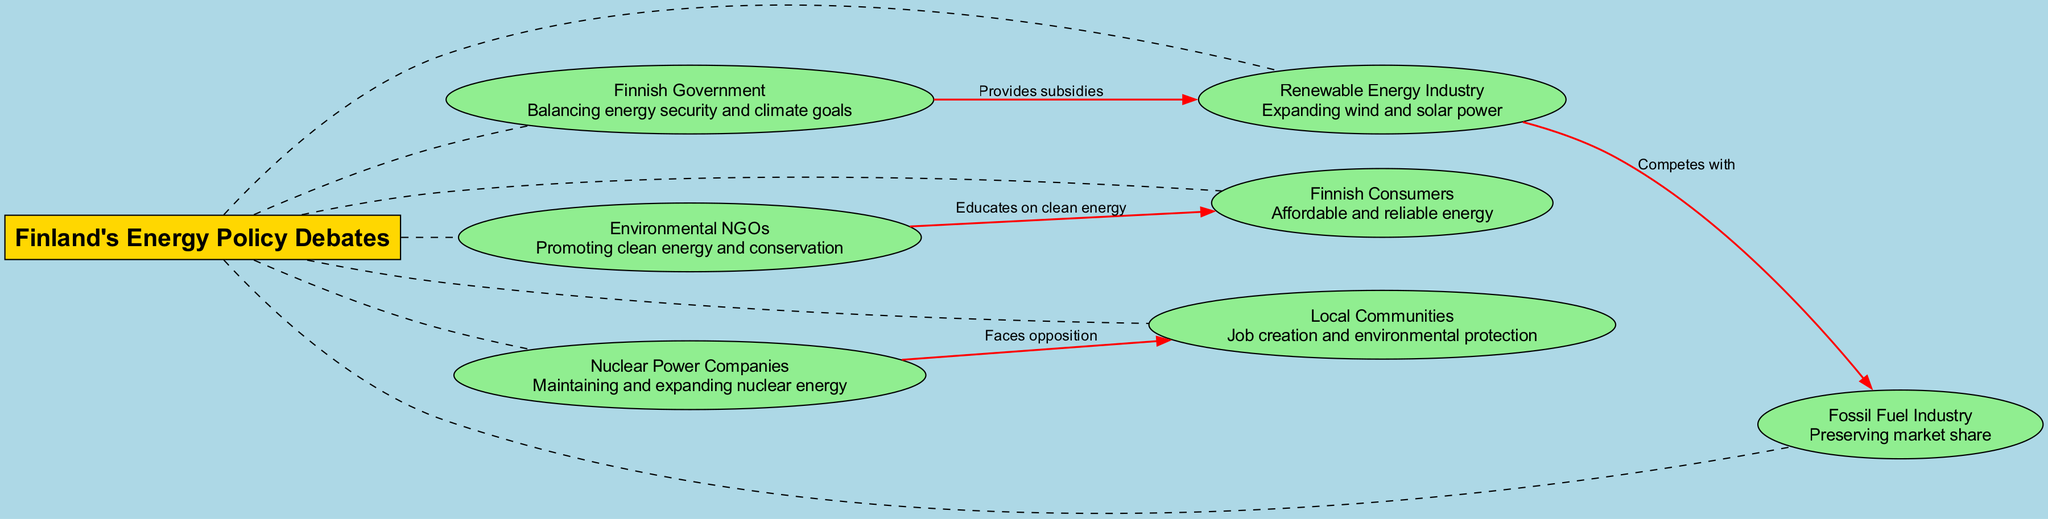What is the central topic of the diagram? The central topic is explicitly stated at the center of the diagram as "Finland's Energy Policy Debates."
Answer: Finland's Energy Policy Debates How many stakeholders are depicted in the diagram? The diagram features a total of seven stakeholders. Each stakeholder is represented by an ellipse connected to the central topic.
Answer: 7 What interest does the Renewable Energy Industry have? The interest of the Renewable Energy Industry is indicated in the diagram as "Expanding wind and solar power." This is shown in the ellipse connected to the central topic.
Answer: Expanding wind and solar power What is the relationship between the Finnish Government and the Renewable Energy Industry? The diagram shows a dashed line connecting the Finnish Government to the Renewable Energy Industry, labeled "Provides subsidies," indicating the nature of their relationship.
Answer: Provides subsidies Which stakeholder faces opposition from Nuclear Power Companies? The arrow directed from Nuclear Power Companies indicates opposition towards Local Communities, demonstrating that this stakeholder is the one facing opposition.
Answer: Local Communities Which two stakeholders compete with each other? The diagram illustrates a direct connection labeled "Competes with" between the Renewable Energy Industry and the Fossil Fuel Industry, indicating their competitive relationship.
Answer: Renewable Energy Industry, Fossil Fuel Industry What interest do Environmental NGOs promote? Environmental NGOs are represented with the interest of "Promoting clean energy and conservation," which is specified in their respective ellipse in the diagram.
Answer: Promoting clean energy and conservation How does the Environmental NGOs connect to Finnish Consumers? The connection from Environmental NGOs to Finnish Consumers is highlighted with the label "Educates on clean energy," indicating the flow of influence from one to the other.
Answer: Educates on clean energy Which group is focused on job creation and environmental protection? The Local Communities group is explicitly mentioned with the interest in "Job creation and environmental protection," as shown in their ellipse within the diagram.
Answer: Local Communities 